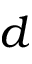<formula> <loc_0><loc_0><loc_500><loc_500>d</formula> 